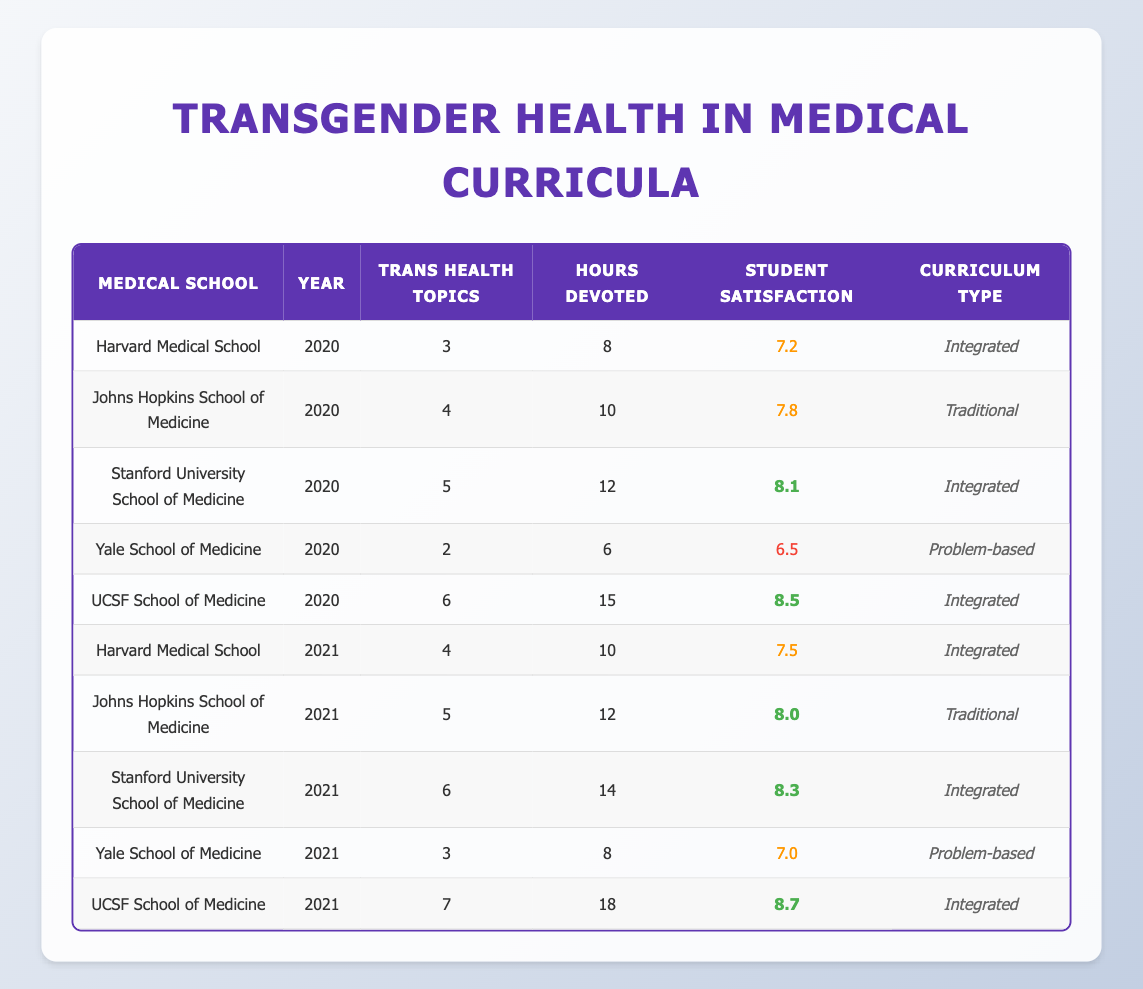What is the highest number of transgender health topics covered in a medical school curriculum for the year 2021? In 2021, UCSF School of Medicine has the highest number of transgender health topics at 7. This is compared to other medical schools listed for 2021.
Answer: 7 Which curriculum type had the lowest student satisfaction rating in 2020? In the table, Yale School of Medicine in 2020 had the lowest student satisfaction rating at 6.5 with a Problem-based curriculum type.
Answer: Problem-based What is the average number of hours devoted to transgender health topics across all medical schools in 2020? To find the average, add the hours devoted: 8 + 10 + 12 + 6 + 15 = 51. Then, divide by the number of medical schools (5): 51 / 5 = 10.2 hours.
Answer: 10.2 Has the student satisfaction rating improved from 2020 to 2021 for Stanford University School of Medicine? For Stanford, the student satisfaction rating increased from 8.1 in 2020 to 8.3 in 2021, indicating an improvement.
Answer: Yes Which school had the same number of transgender health topics covered in both 2020 and 2021? Harvard Medical School had 3 topics in 2020 and 4 topics in 2021, while Johns Hopkins School of Medicine had 4 in 2020 and 5 in 2021, so no school had the same number in both years.
Answer: No What is the difference in student satisfaction ratings between the UCSF School of Medicine in 2020 and 2021? UCSF had a rating of 8.5 in 2020 and 8.7 in 2021. The difference is calculated as 8.7 - 8.5 = 0.2.
Answer: 0.2 Did all medical schools cover more transgender health topics in 2021 compared to 2020? Checking the number of topics: Harvard (3 to 4), Johns Hopkins (4 to 5), Stanford (5 to 6), Yale (2 to 3), UCSF (6 to 7). Yale is the only school that did not increase topics.
Answer: No Which medical school has the highest average student satisfaction across both years? Calculating averages: Harvard (7.2 + 7.5)/2 = 7.35, Johns Hopkins (7.8 + 8.0)/2 = 7.9, Stanford (8.1 + 8.3)/2 = 8.2, Yale (6.5 + 7.0)/2 = 6.75, UCSF (8.5 + 8.7)/2 = 8.6. UCSF has the highest average.
Answer: UCSF 